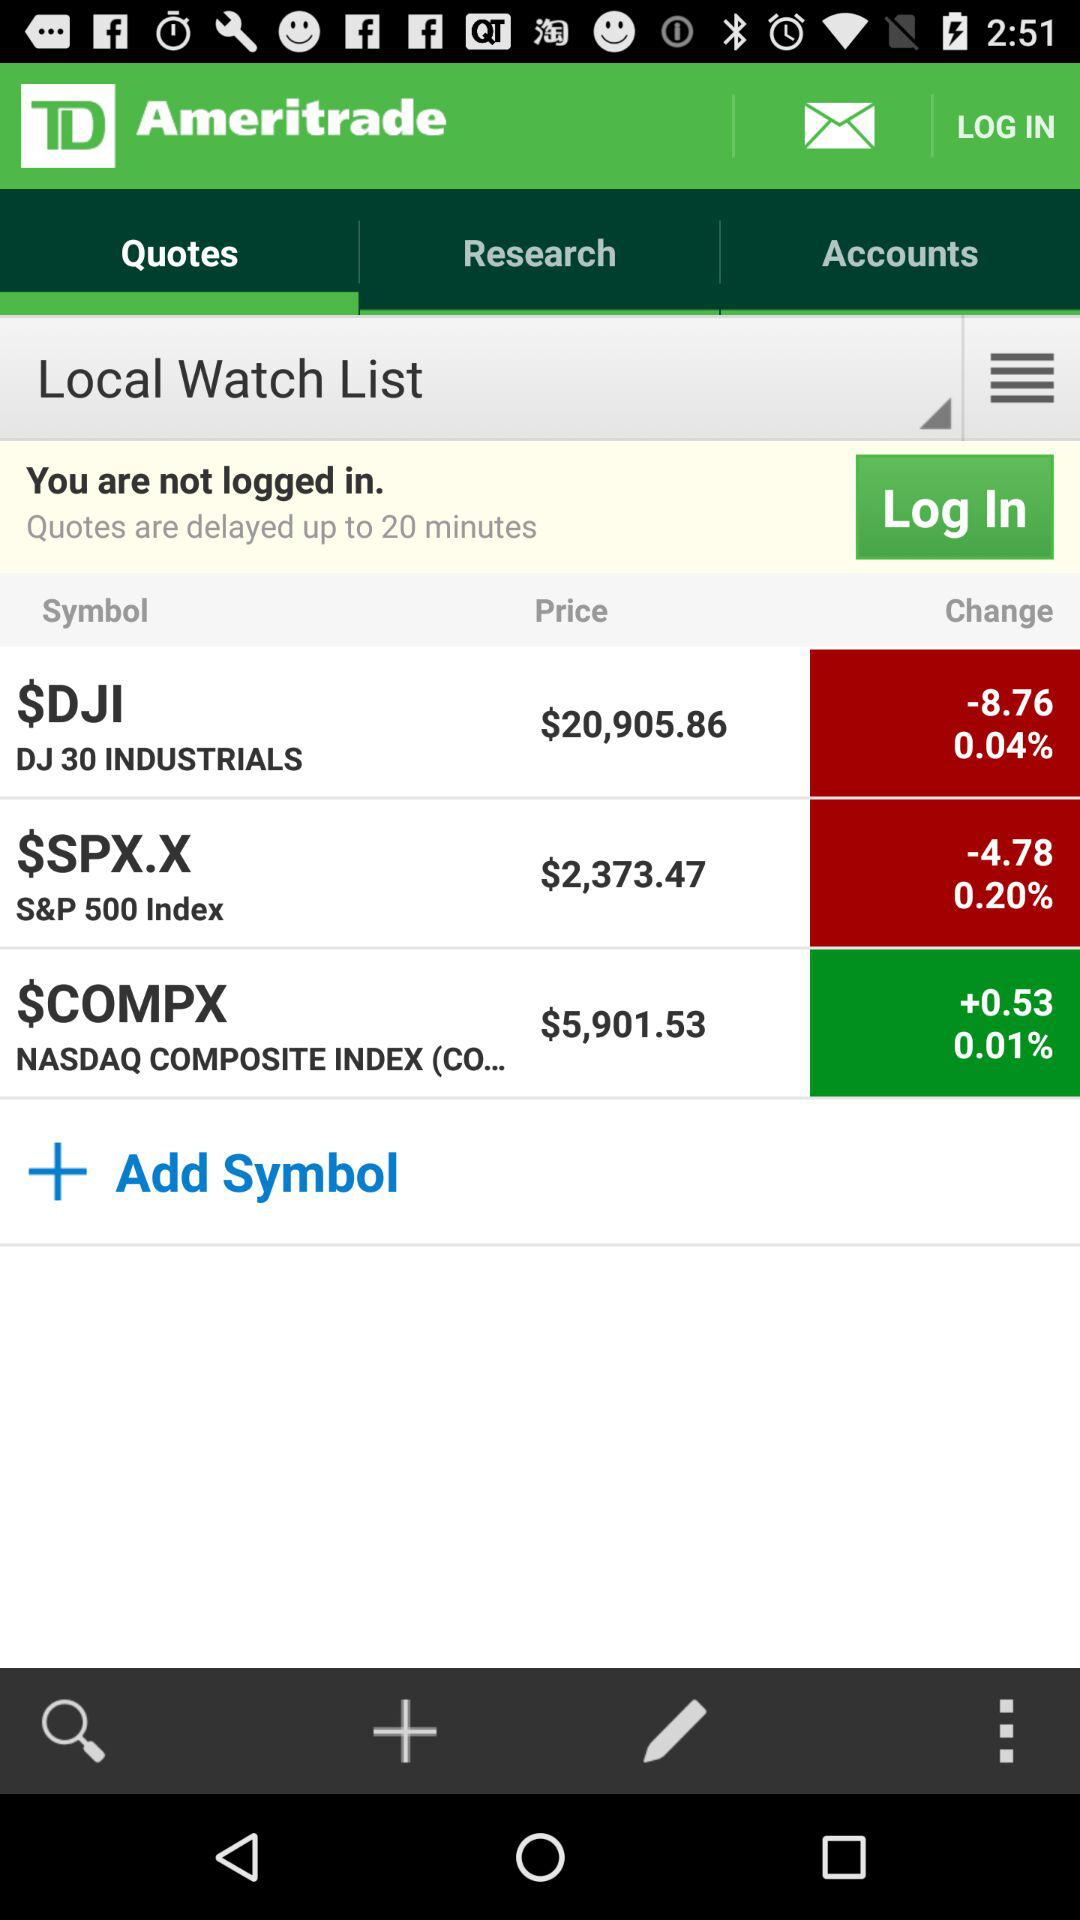What is the price of the S&P 500 index? The price of the S&P 500 index is $2,373.47. 